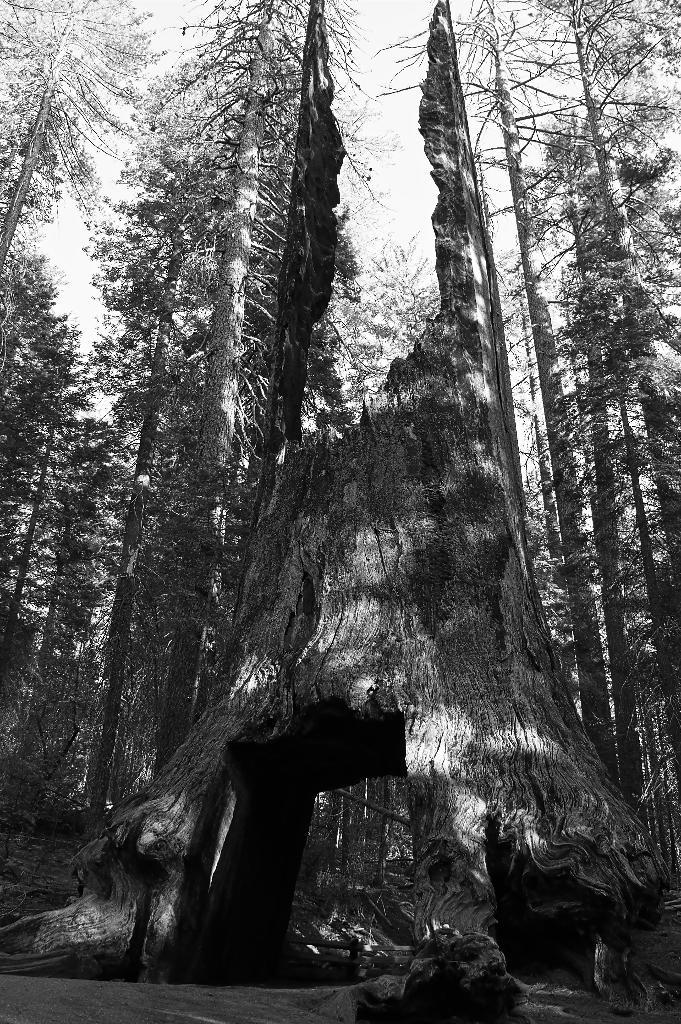What is the color scheme of the image? The image is black and white. What is the main subject in the foreground of the image? There is a tree trunk in the front of the image. What can be seen in the background of the image? There are trees and the sky visible in the background of the image. What type of stitch is used to create the mist in the image? There is no mist present in the image, and therefore no stitch can be associated with it. 